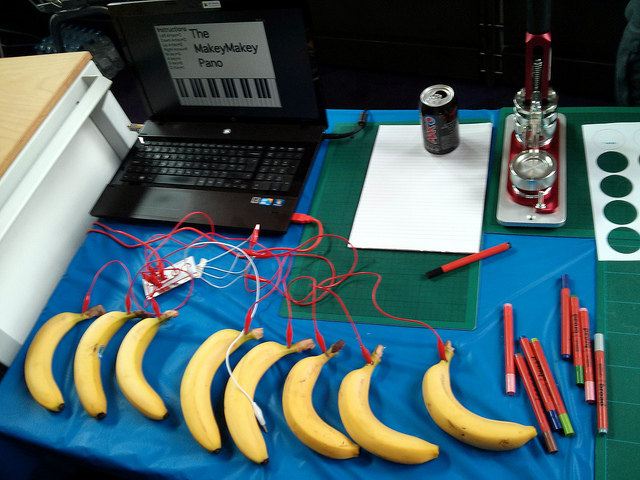Identify the text displayed in this image. The MakeyMakey Pano 